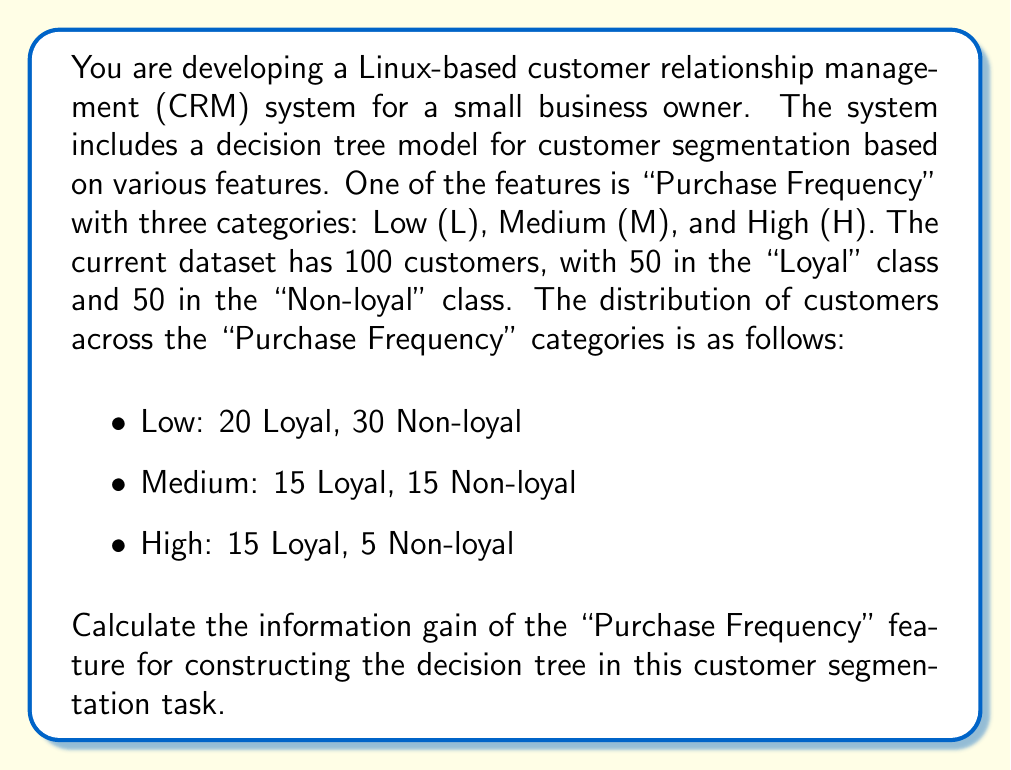Can you solve this math problem? To calculate the information gain of the "Purchase Frequency" feature, we need to follow these steps:

1. Calculate the entropy of the target variable (Loyalty)
2. Calculate the entropy of each category in the "Purchase Frequency" feature
3. Calculate the weighted average entropy of the "Purchase Frequency" feature
4. Calculate the information gain

Step 1: Entropy of the target variable (Loyalty)
The entropy of a binary classification is given by:
$$H(S) = -p_1 \log_2(p_1) - p_2 \log_2(p_2)$$

Where $p_1$ and $p_2$ are the probabilities of each class.

$p_1 = p_2 = 0.5$ (50 Loyal and 50 Non-loyal out of 100)

$$H(S) = -0.5 \log_2(0.5) - 0.5 \log_2(0.5) = 1$$

Step 2: Entropy of each category in "Purchase Frequency"

Low (L):
$p(\text{Loyal}|L) = 20/50 = 0.4$
$p(\text{Non-loyal}|L) = 30/50 = 0.6$
$$H(S|L) = -0.4 \log_2(0.4) - 0.6 \log_2(0.6) \approx 0.9710$$

Medium (M):
$p(\text{Loyal}|M) = 15/30 = 0.5$
$p(\text{Non-loyal}|M) = 15/30 = 0.5$
$$H(S|M) = -0.5 \log_2(0.5) - 0.5 \log_2(0.5) = 1$$

High (H):
$p(\text{Loyal}|H) = 15/20 = 0.75$
$p(\text{Non-loyal}|H) = 5/20 = 0.25$
$$H(S|H) = -0.75 \log_2(0.75) - 0.25 \log_2(0.25) \approx 0.8113$$

Step 3: Weighted average entropy of "Purchase Frequency"
$$H(S|\text{Purchase Frequency}) = \sum_{i \in \{L,M,H\}} p(i) \cdot H(S|i)$$

$p(L) = 50/100 = 0.5$
$p(M) = 30/100 = 0.3$
$p(H) = 20/100 = 0.2$

$$H(S|\text{Purchase Frequency}) = 0.5 \cdot 0.9710 + 0.3 \cdot 1 + 0.2 \cdot 0.8113 \approx 0.9377$$

Step 4: Information Gain
The information gain is the difference between the entropy of the target variable and the weighted average entropy of the feature:

$$\text{IG}(\text{Purchase Frequency}) = H(S) - H(S|\text{Purchase Frequency})$$
$$\text{IG}(\text{Purchase Frequency}) = 1 - 0.9377 \approx 0.0623$$
Answer: The information gain of the "Purchase Frequency" feature for constructing the decision tree in this customer segmentation task is approximately 0.0623 bits. 